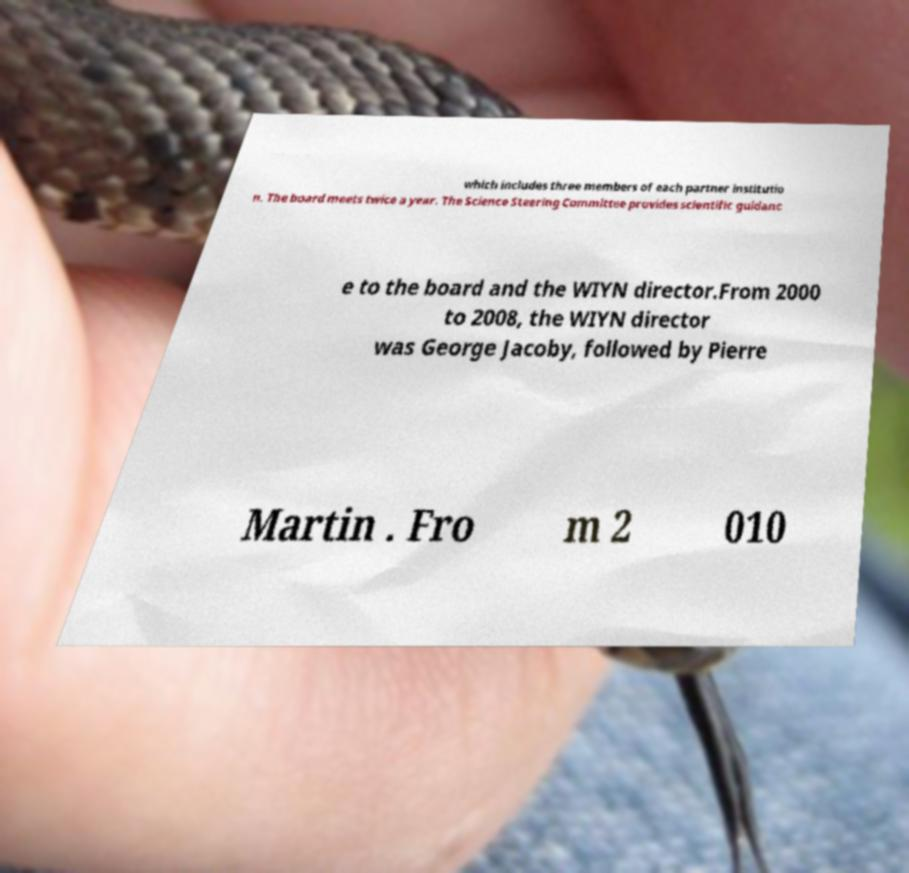I need the written content from this picture converted into text. Can you do that? which includes three members of each partner institutio n. The board meets twice a year. The Science Steering Committee provides scientific guidanc e to the board and the WIYN director.From 2000 to 2008, the WIYN director was George Jacoby, followed by Pierre Martin . Fro m 2 010 